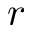Convert formula to latex. <formula><loc_0><loc_0><loc_500><loc_500>r</formula> 